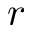Convert formula to latex. <formula><loc_0><loc_0><loc_500><loc_500>r</formula> 